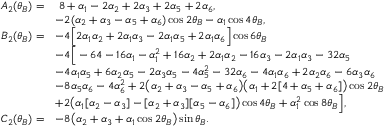Convert formula to latex. <formula><loc_0><loc_0><loc_500><loc_500>\begin{array} { r l } { \quad A _ { 2 } ( \theta _ { B } ) = } & { \, 8 + \alpha _ { 1 } - 2 \alpha _ { 2 } + 2 \alpha _ { 3 } + 2 \alpha _ { 5 } + 2 \alpha _ { 6 } , } \\ & { - 2 ( \alpha _ { 2 } + \alpha _ { 3 } - \alpha _ { 5 } + \alpha _ { 6 } ) \cos { 2 \theta _ { B } } - \alpha _ { 1 } \cos { 4 \theta _ { B } } , } \\ { B _ { 2 } ( \theta _ { B } ) = } & { - 4 \left [ 2 \alpha _ { 1 } \alpha _ { 2 } + 2 \alpha _ { 1 } \alpha _ { 3 } - 2 \alpha _ { 1 } \alpha _ { 5 } + 2 \alpha _ { 1 } \alpha _ { 6 } \right ] \cos { 6 \theta _ { B } } } \\ & { - 4 \left [ - 6 4 - 1 6 \alpha _ { 1 } - \alpha _ { 1 } ^ { 2 } + 1 6 \alpha _ { 2 } + 2 \alpha _ { 1 } \alpha _ { 2 } - 1 6 \alpha _ { 3 } - 2 \alpha _ { 1 } \alpha _ { 3 } - 3 2 \alpha _ { 5 } } \\ & { - 4 \alpha _ { 1 } \alpha _ { 5 } + 6 \alpha _ { 2 } \alpha _ { 5 } - 2 \alpha _ { 3 } \alpha _ { 5 } - 4 \alpha _ { 5 } ^ { 2 } - 3 2 \alpha _ { 6 } - 4 \alpha _ { 1 } \alpha _ { 6 } + 2 \alpha _ { 2 } \alpha _ { 6 } - 6 \alpha _ { 3 } \alpha _ { 6 } } \\ & { - 8 \alpha _ { 5 } \alpha _ { 6 } - 4 \alpha _ { 6 } ^ { 2 } + 2 \left ( \alpha _ { 2 } + \alpha _ { 3 } - \alpha _ { 5 } + \alpha _ { 6 } \right ) \left ( \alpha _ { 1 } + 2 [ 4 + \alpha _ { 5 } + \alpha _ { 6 } ] \right ) \cos { 2 \theta _ { B } } } \\ & { + 2 \left ( \alpha _ { 1 } [ \alpha _ { 2 } - \alpha _ { 3 } ] - [ \alpha _ { 2 } + \alpha _ { 3 } ] [ \alpha _ { 5 } - \alpha _ { 6 } ] \right ) \cos { 4 \theta _ { B } } + \alpha _ { 1 } ^ { 2 } \cos { 8 \theta _ { B } } \right ] , } \\ { C _ { 2 } ( \theta _ { B } ) = } & { - 8 \left ( \alpha _ { 2 } + \alpha _ { 3 } + \alpha _ { 1 } \cos { 2 \theta _ { B } } \right ) \sin { \theta _ { B } } . } \end{array}</formula> 